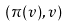Convert formula to latex. <formula><loc_0><loc_0><loc_500><loc_500>( \pi ( v ) , v )</formula> 